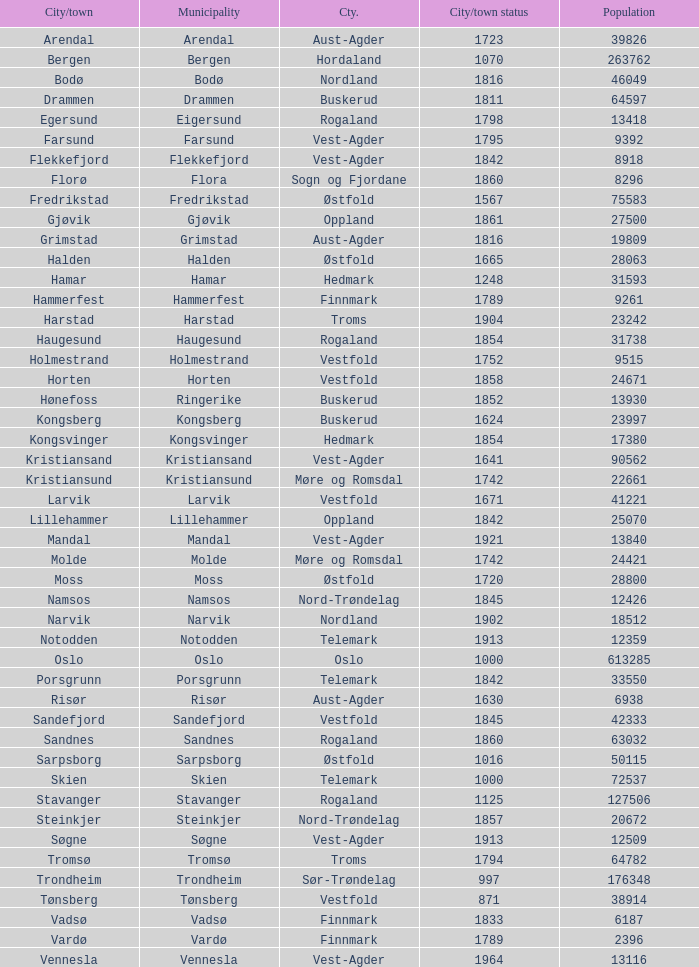What are the urban areas situated in the municipality of horten? Horten. 